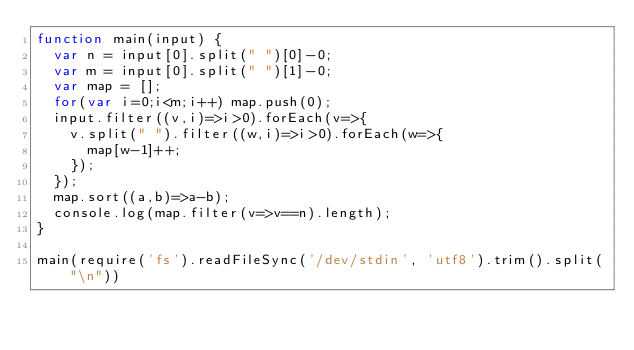<code> <loc_0><loc_0><loc_500><loc_500><_JavaScript_>function main(input) {
  var n = input[0].split(" ")[0]-0;
  var m = input[0].split(" ")[1]-0;
  var map = [];
  for(var i=0;i<m;i++) map.push(0);
  input.filter((v,i)=>i>0).forEach(v=>{
    v.split(" ").filter((w,i)=>i>0).forEach(w=>{
      map[w-1]++;
    });
  });
  map.sort((a,b)=>a-b);
  console.log(map.filter(v=>v==n).length);
}

main(require('fs').readFileSync('/dev/stdin', 'utf8').trim().split("\n"))
</code> 